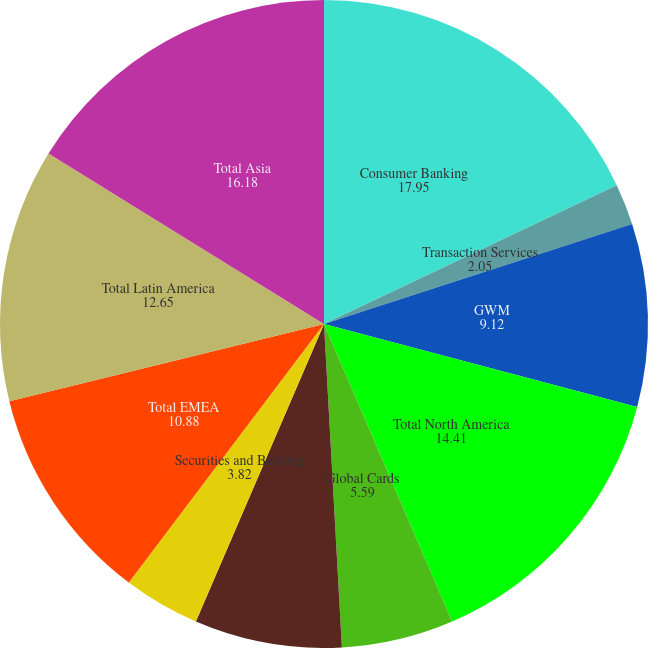Convert chart to OTSL. <chart><loc_0><loc_0><loc_500><loc_500><pie_chart><fcel>Consumer Banking<fcel>Transaction Services<fcel>GWM<fcel>Total North America<fcel>Global Cards<fcel>ICG<fcel>Securities and Banking<fcel>Total EMEA<fcel>Total Latin America<fcel>Total Asia<nl><fcel>17.95%<fcel>2.05%<fcel>9.12%<fcel>14.41%<fcel>5.59%<fcel>7.35%<fcel>3.82%<fcel>10.88%<fcel>12.65%<fcel>16.18%<nl></chart> 